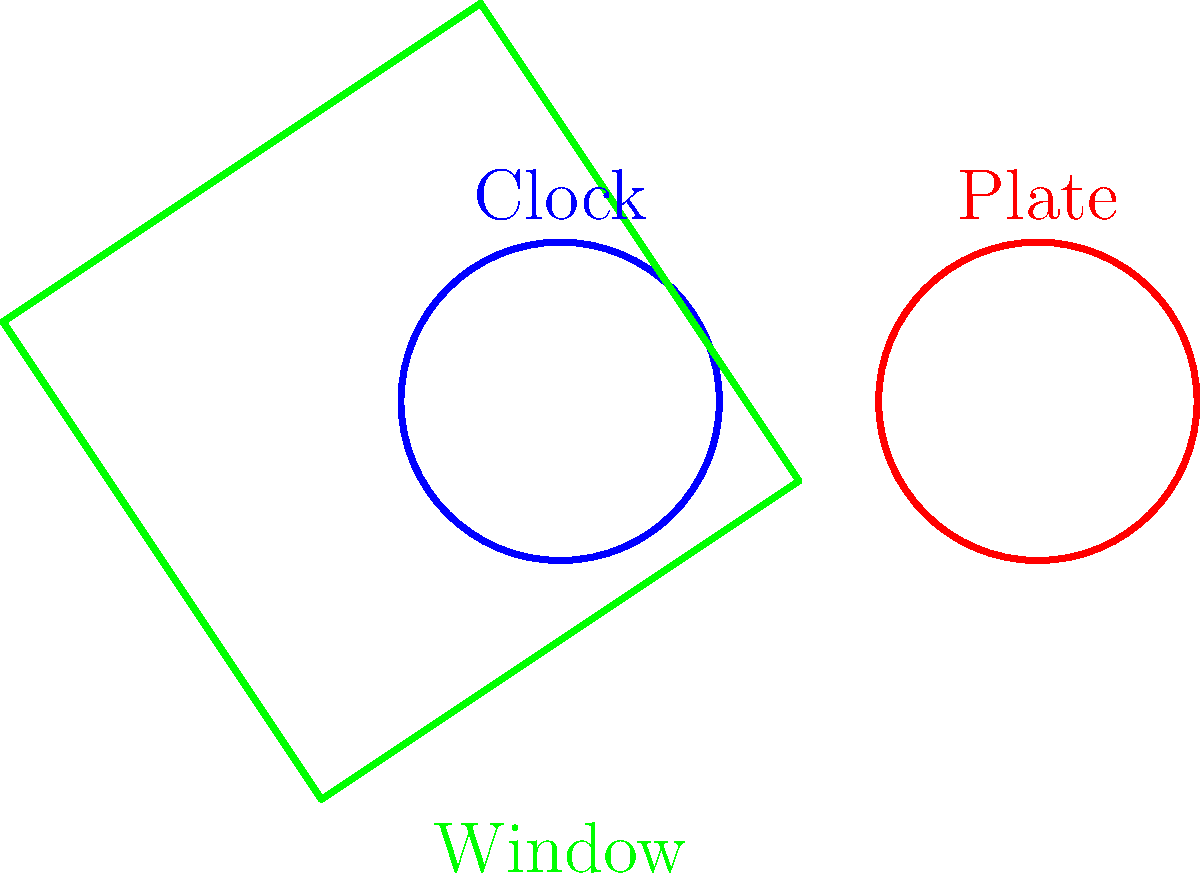Look at the picture carefully. Can you match each object with its shape? Which object is a square? Let's look at each object one by one:

1. The clock: It's round and has no corners. This is a circle shape.

2. The plate: It's also round with no corners. This is another circle shape.

3. The window: It has four equal sides and four corners. This is a square shape.

To find the square, we need to look for an object with four equal sides and four corners. The window is the only object that fits this description.
Answer: Window 